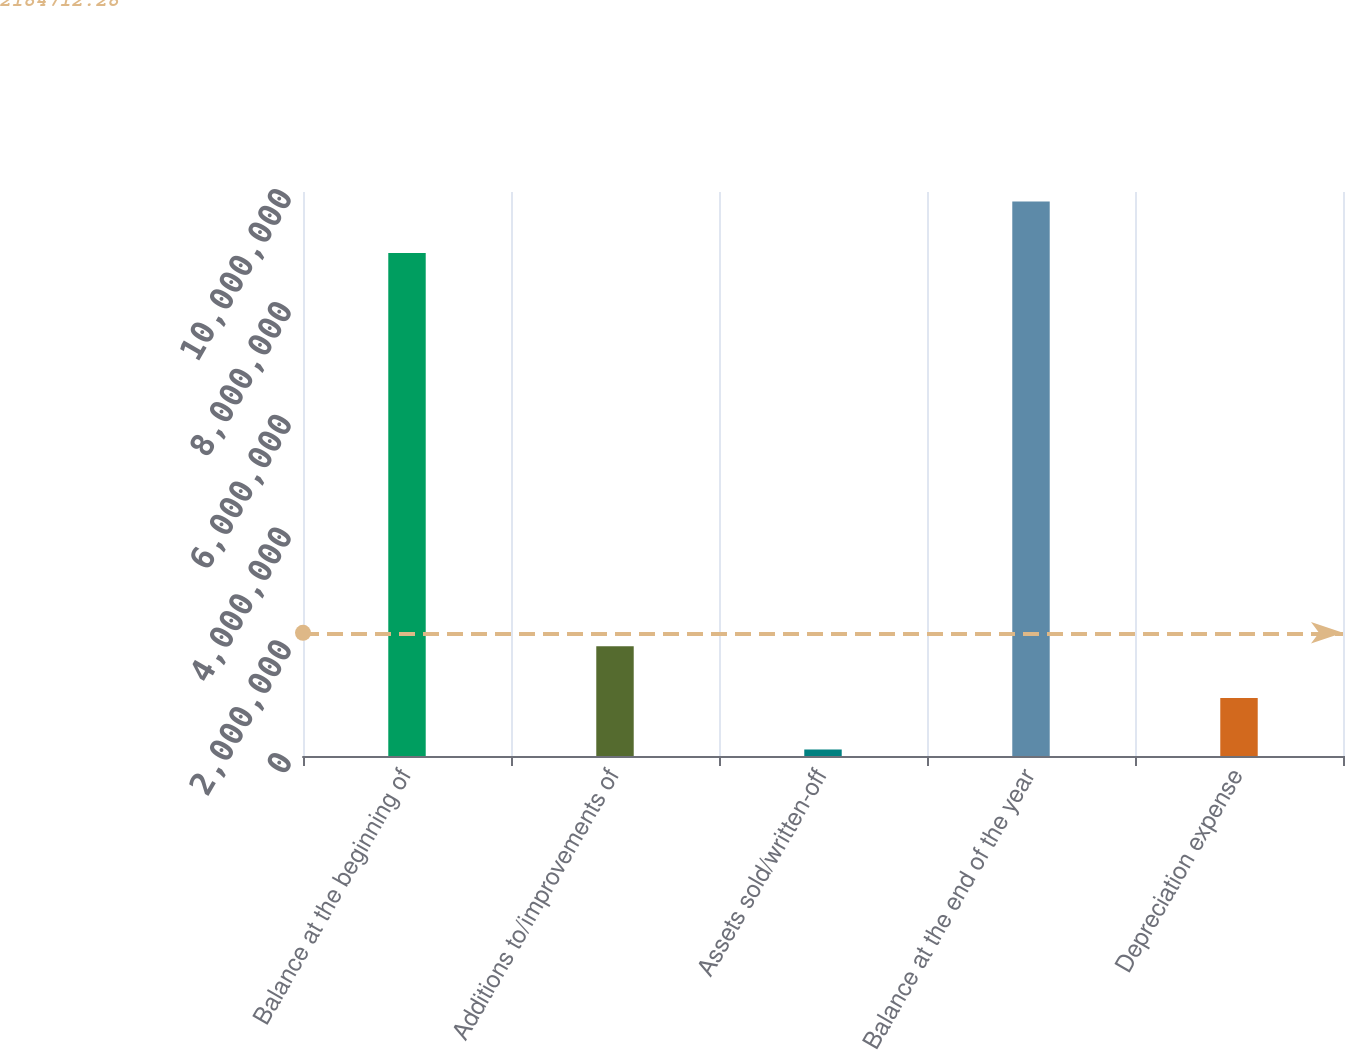<chart> <loc_0><loc_0><loc_500><loc_500><bar_chart><fcel>Balance at the beginning of<fcel>Additions to/improvements of<fcel>Assets sold/written-off<fcel>Balance at the end of the year<fcel>Depreciation expense<nl><fcel>8.91779e+06<fcel>1.94409e+06<fcel>115955<fcel>9.83185e+06<fcel>1.03002e+06<nl></chart> 